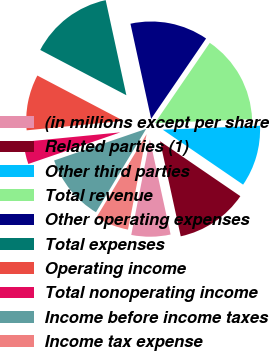<chart> <loc_0><loc_0><loc_500><loc_500><pie_chart><fcel>(in millions except per share<fcel>Related parties (1)<fcel>Other third parties<fcel>Total revenue<fcel>Other operating expenses<fcel>Total expenses<fcel>Operating income<fcel>Total nonoperating income<fcel>Income before income taxes<fcel>Income tax expense<nl><fcel>6.48%<fcel>12.04%<fcel>10.19%<fcel>14.81%<fcel>12.96%<fcel>13.89%<fcel>9.26%<fcel>3.71%<fcel>11.11%<fcel>5.56%<nl></chart> 